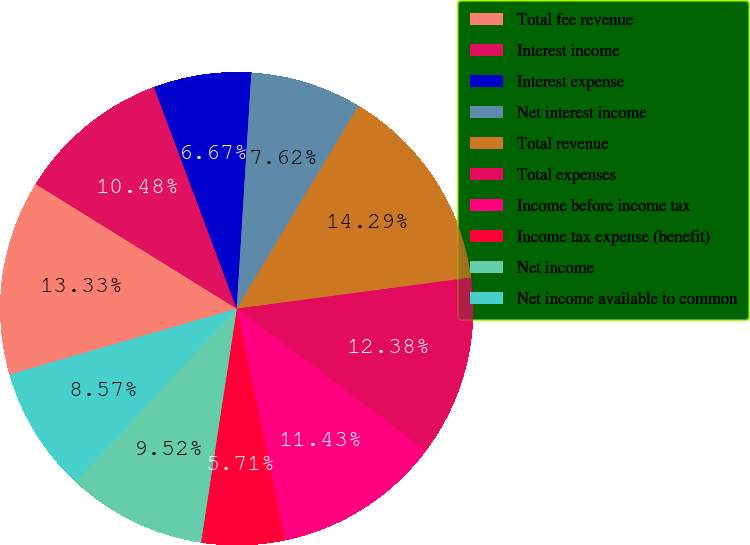Convert chart to OTSL. <chart><loc_0><loc_0><loc_500><loc_500><pie_chart><fcel>Total fee revenue<fcel>Interest income<fcel>Interest expense<fcel>Net interest income<fcel>Total revenue<fcel>Total expenses<fcel>Income before income tax<fcel>Income tax expense (benefit)<fcel>Net income<fcel>Net income available to common<nl><fcel>13.33%<fcel>10.48%<fcel>6.67%<fcel>7.62%<fcel>14.29%<fcel>12.38%<fcel>11.43%<fcel>5.71%<fcel>9.52%<fcel>8.57%<nl></chart> 